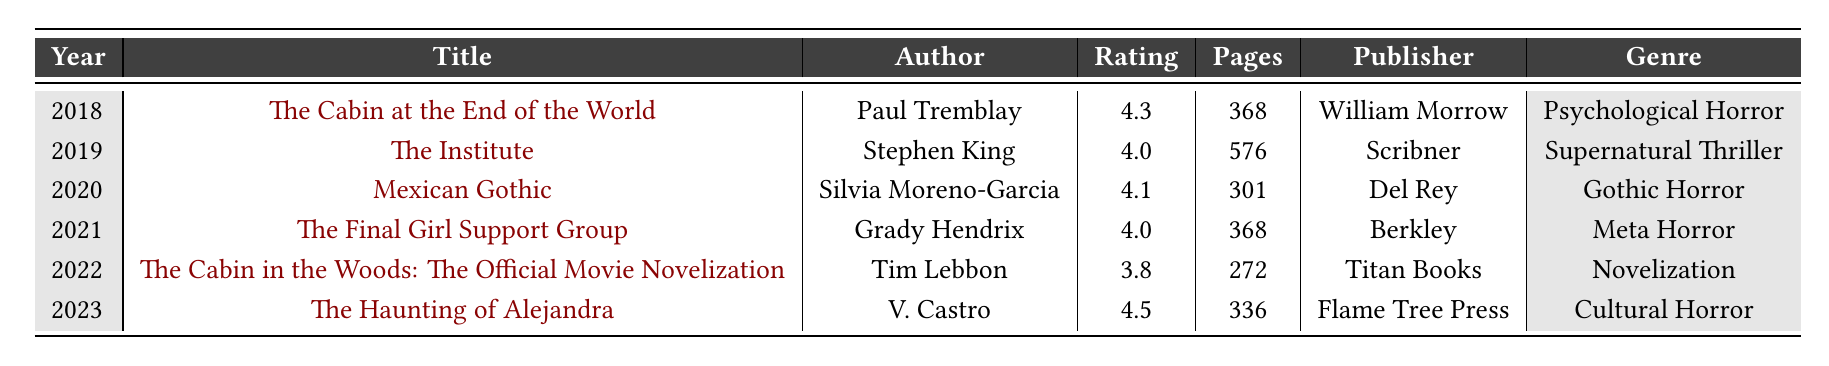What is the title of the highest-rated horror book in the table? By looking through the "Rating" column, we see that "The Haunting of Alejandra" has the highest rating of 4.5, making it the highest-rated book. We then refer to the "Title" column to find that it is "The Haunting of Alejandra."
Answer: The Haunting of Alejandra How many pages does "The Institute" have? We locate "The Institute" in the table and check the corresponding "Pages" column, which indicates it has 576 pages.
Answer: 576 pages What genre does "Mexican Gothic" belong to? We can find "Mexican Gothic" in the table and look at its corresponding "Genre" column, which states it is classified as Gothic Horror.
Answer: Gothic Horror What is the average rating of the horror books listed in the table? We first add up all the ratings: 4.3 + 4.0 + 4.1 + 4.0 + 3.8 + 4.5 = 24.7. Then, we divide by the total number of books, which is 6: 24.7 / 6 ≈ 4.12.
Answer: Approximately 4.12 Which author has released two books in the last five years? We observe the authors of the books listed and see that none of the authors have released multiple books in the table; all authors only have one work listed. Thus, the answer is no.
Answer: No Is the rating of "The Cabin at the Woods: The Official Movie Novelization" lower than 4.0? We check the rating for this book in the "Rating" column, which is 3.8, confirming it is indeed lower than 4.0. Therefore, the answer is yes.
Answer: Yes What was the most recent horror book release, and who is the author? Looking through the "Year" column, we find the most recent year is 2023, which has "The Haunting of Alejandra" as the title and V. Castro as the author.
Answer: The Haunting of Alejandra, V. Castro How many horror books released have a rating of 4.0 or higher? We examine each rating and find four books with ratings of 4.0 or higher: "The Cabin at the End of the World" (4.3), "The Institute" (4.0), "Mexican Gothic" (4.1), and "The Haunting of Alejandra" (4.5). This gives us a total of four books.
Answer: 4 books What is the difference in pages between the longest and shortest horror books in the table? The longest horror book is "The Institute" with 576 pages, while the shortest is "The Cabin in the Woods: The Official Movie Novelization" with 272 pages. The difference is 576 - 272 = 304 pages.
Answer: 304 pages How many of the books listed are published by Berkley? By examining the "Publisher" column, we identify that only one book, "The Final Girl Support Group," is published by Berkley.
Answer: 1 book 